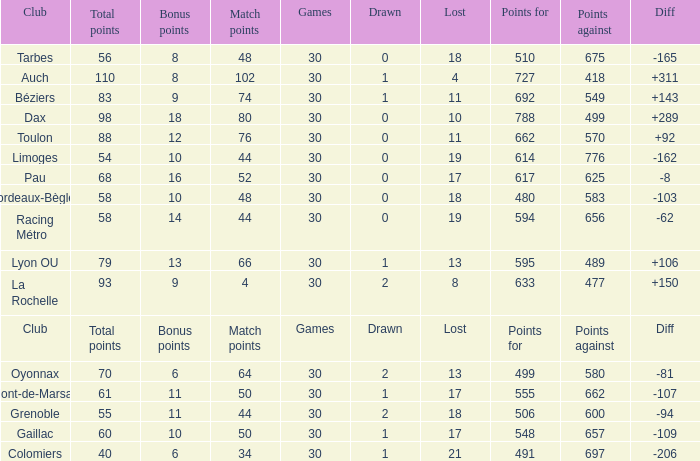What is the value of match points when the points for is 570? 76.0. 